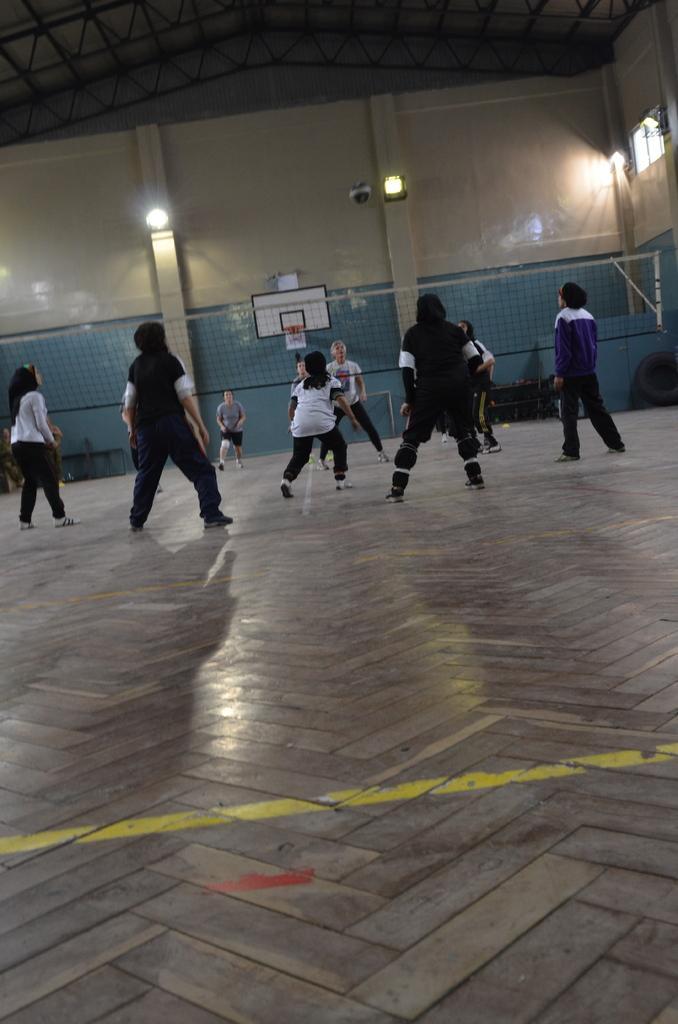How would you summarize this image in a sentence or two? In the foreground of this image, there are persons standing on the floor and in between them, there is a net. In the background, there is a wall, a ball in the air, few lights and the inside roof of the hall. 